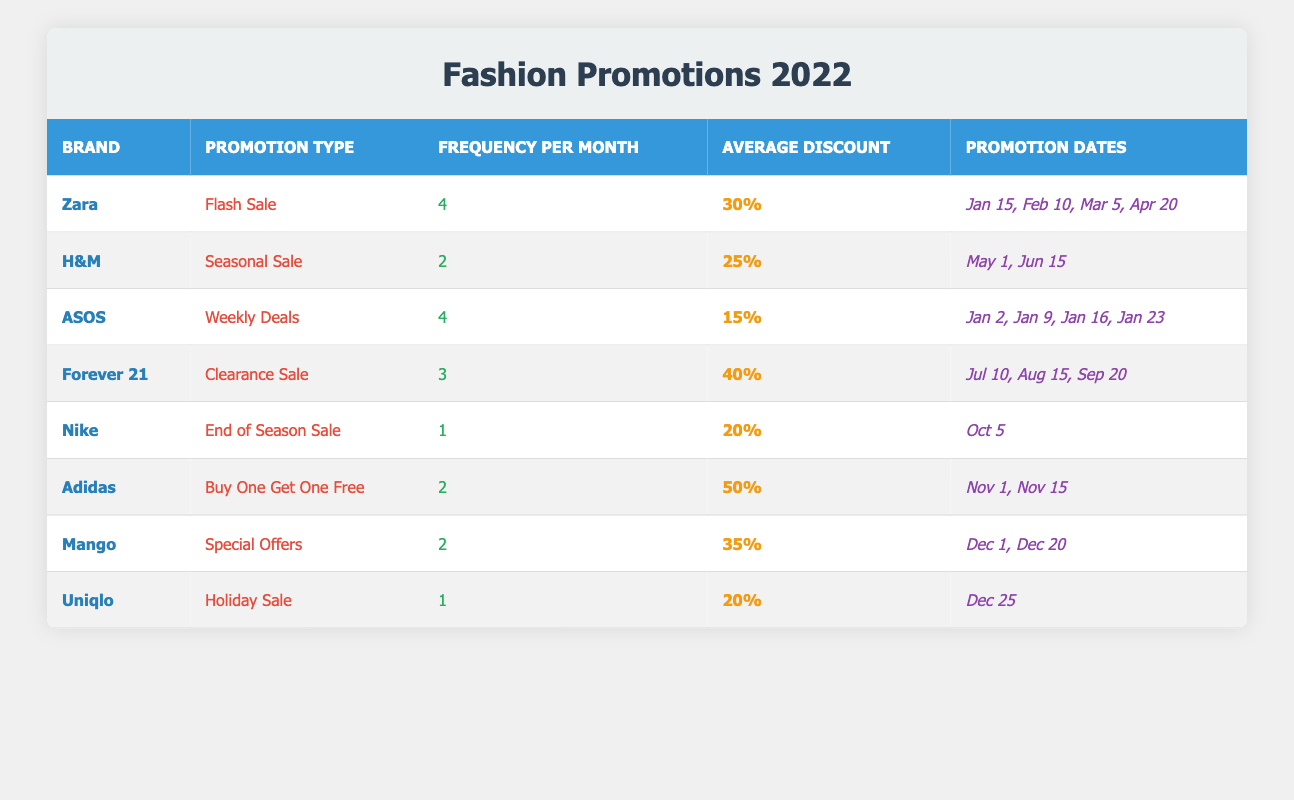What brand has the highest frequency of online promotions per month? From the table, Zara and ASOS both have a frequency of 4 promotions per month, which is the highest compared to other brands listed.
Answer: Zara and ASOS What is the average discount percentage across all brands? To find the average discount percentage, sum the average discounts of all brands: (30 + 25 + 15 + 40 + 20 + 50 + 35 + 20) = 235. There are 8 brands, so the average discount is 235/8 = 29.375%.
Answer: 29.38% Which brand offers the lowest average discount percentage? By examining the discounts listed, ASOS has the lowest average discount percentage at 15%.
Answer: ASOS Is it true that Adidas has more frequency of promotions than H&M? H&M has a frequency of 2 promotions per month, while Adidas also has 2 promotions per month, so the statement is false.
Answer: No Which brand has the most diverse promotion types? Zara has the highest frequency of flash sales, while Forever 21 offers clearance sales. No brand stands out significantly for having diverse types since most have only one type; therefore, the statement is subjective.
Answer: N/A Calculate the total number of promotions for Nike in 2022. Nike has only one promotion listed for October, so the total number of promotions for Nike is 1.
Answer: 1 Which brand had promotions in January 2022? The brands listed with promotions in January 2022 are Zara and ASOS.
Answer: Zara and ASOS How often does Forever 21 run promotions compared to Uniqlo? Forever 21 runs promotions 3 times per month, while Uniqlo runs them 1 time per month. Therefore, Forever 21 runs promotions more often than Uniqlo.
Answer: Forever 21 runs more often Which two brands had promotional events in December? According to the table, Mango and Uniqlo both had promotional events in December.
Answer: Mango and Uniqlo What is the median average discount percentage among all brands? After arranging the average discounts in ascending order: 15%, 20%, 20%, 25%, 30%, 35%, 40%, 50%, the median (the average of the 4th and 5th values) is (25 + 30) / 2 = 27.5%.
Answer: 27.5% 